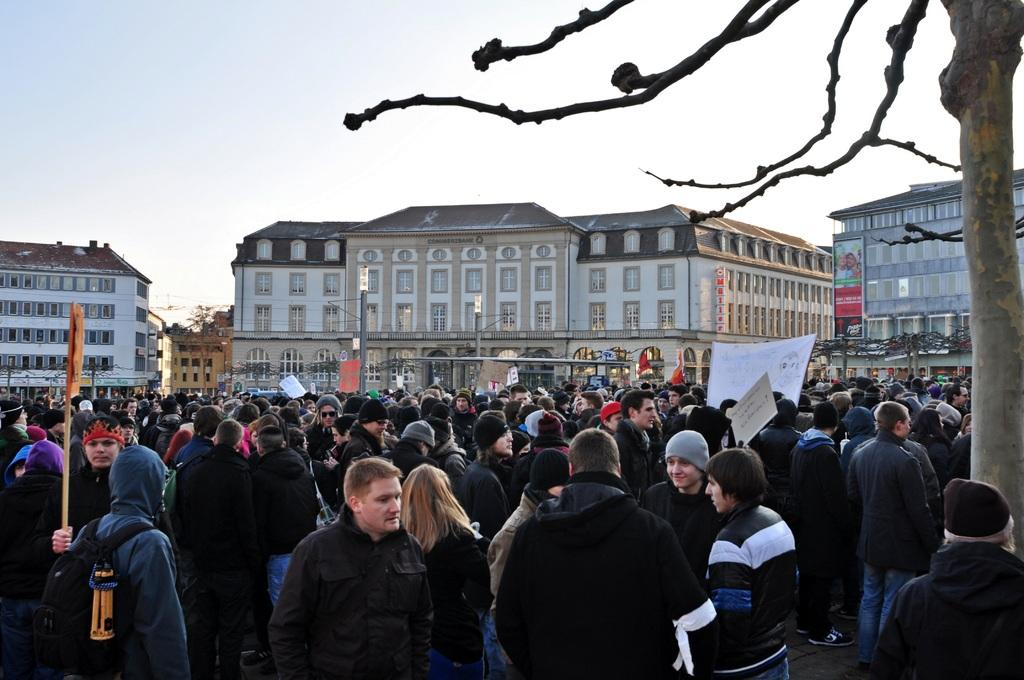What are the people at the bottom of the image doing? The people at the bottom of the image are standing and holding boards. What can be seen in the background of the image? There are buildings in the background of the image. What type of vegetation is on the right side of the image? There is a tree on the right side of the image. What is visible at the top of the image? The sky is visible at the top of the image. Where is the hydrant located in the image? There is no hydrant present in the image. What type of vessel is being used by the people at the bottom of the image? The people at the bottom of the image are holding boards, not a vessel. Can you tell me how many basketballs are visible in the image? There are no basketballs present in the image. 